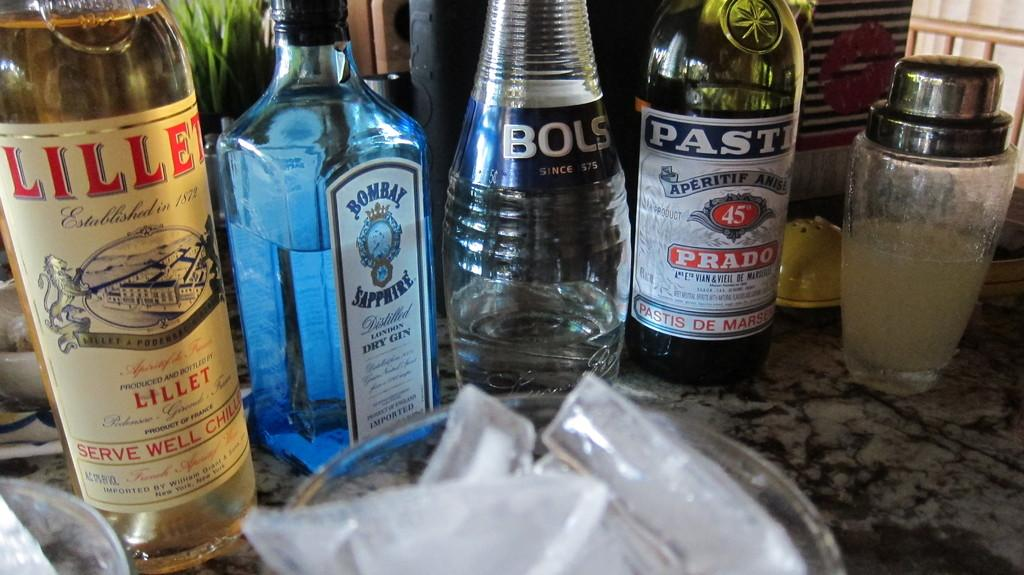Provide a one-sentence caption for the provided image. The cocktail contains four types of alcohol, including Prado. 